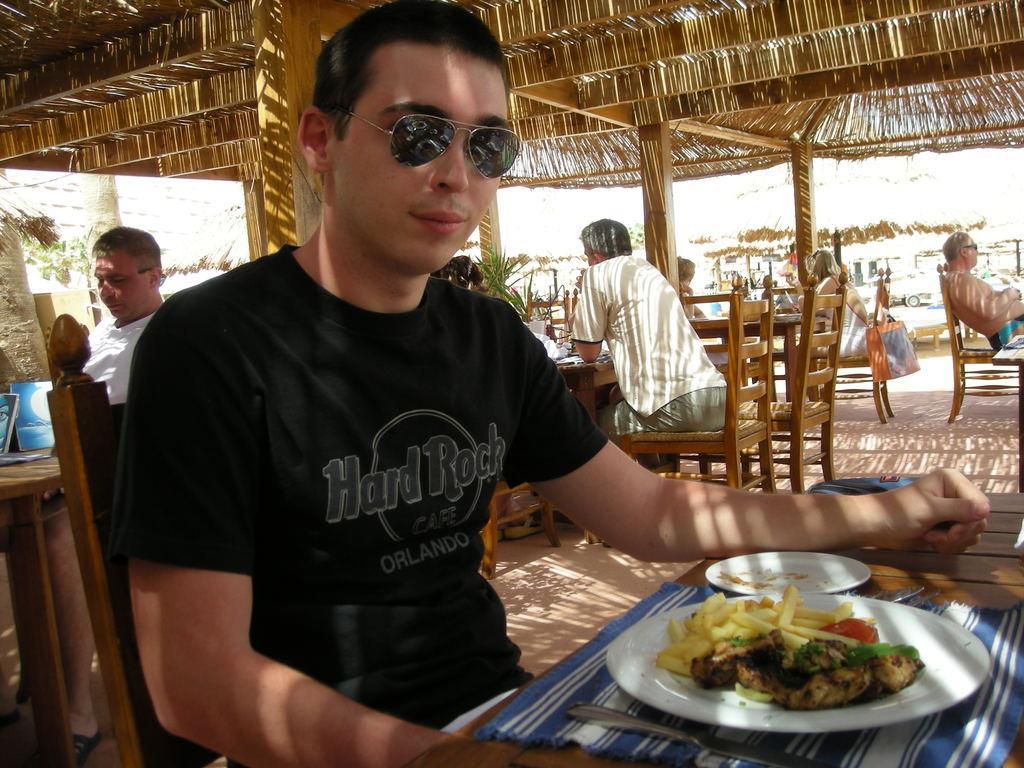Describe this image in one or two sentences. In the center of the image there is a person sitting in the chair at the table. On the table we can see food in the plate and knife. In the background we can see persons, chairs, tables and tent. 